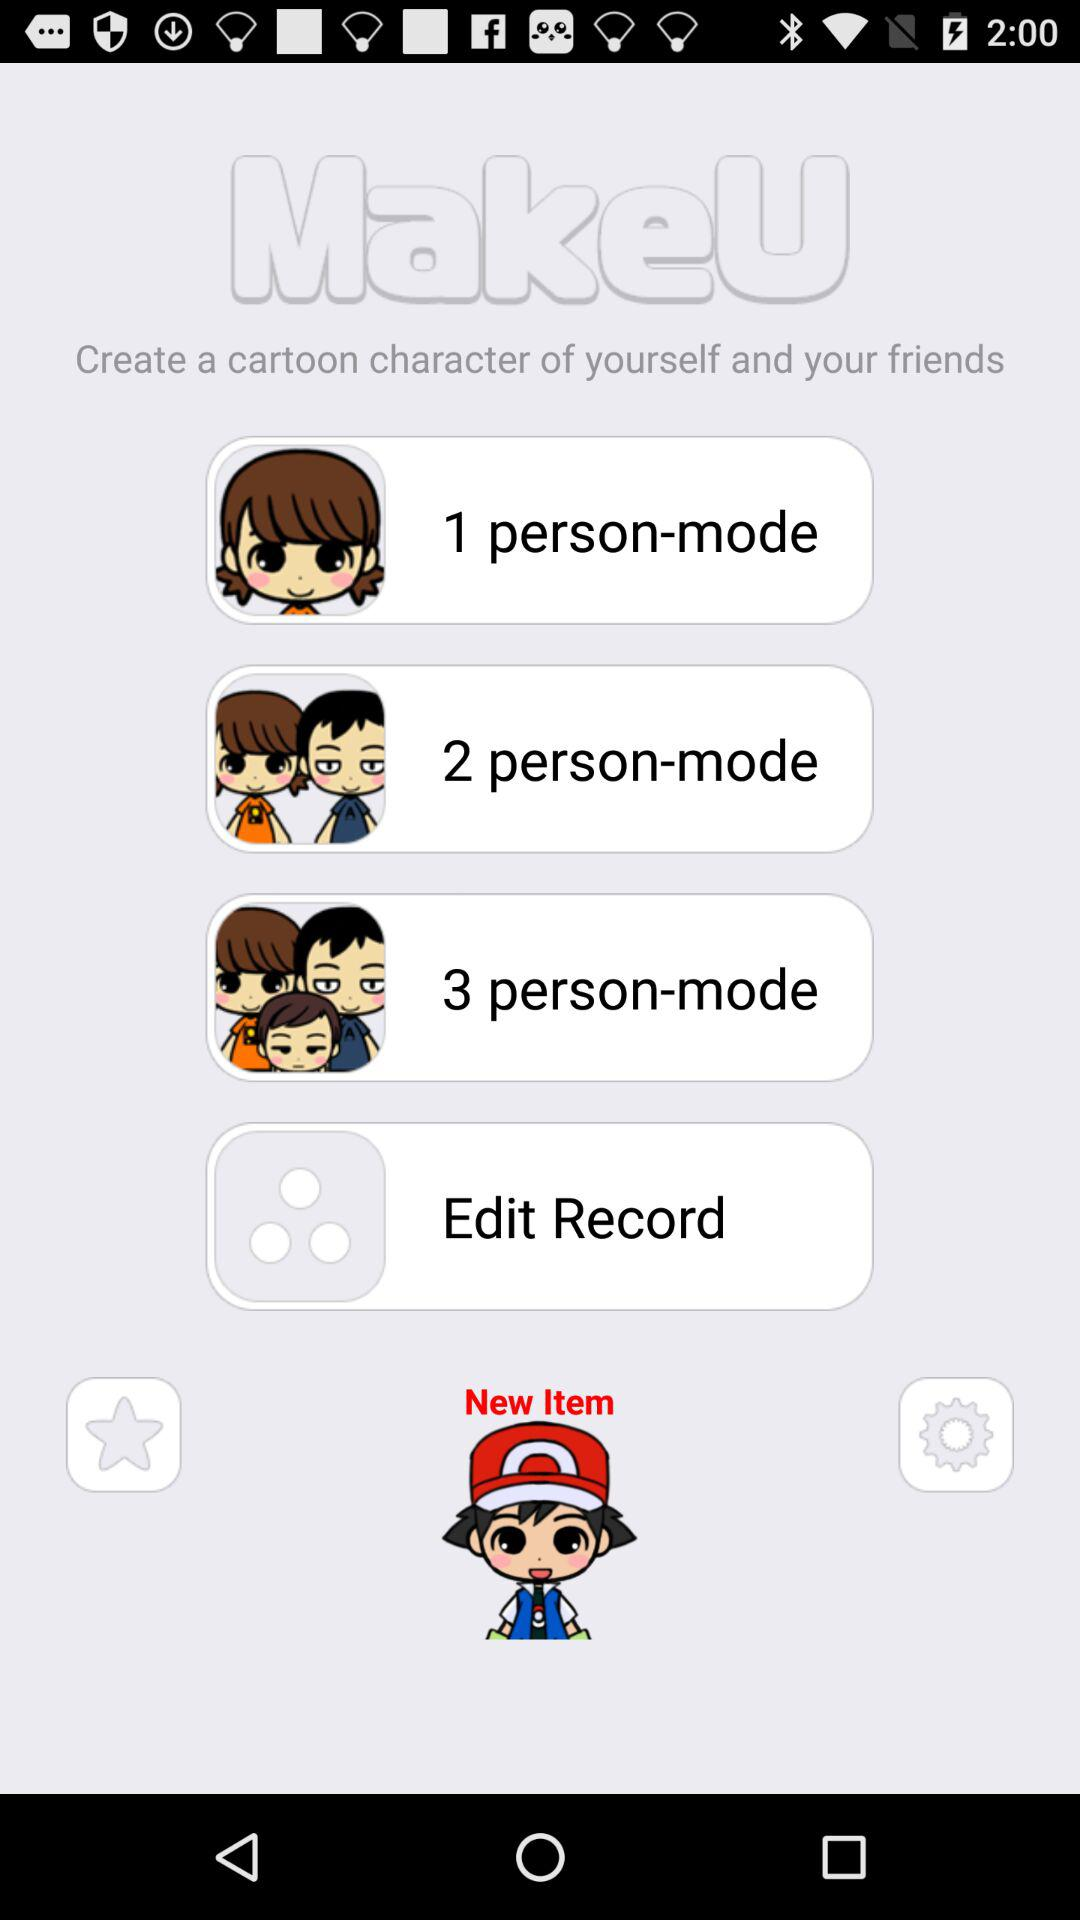How many more people can be drawn in the 3 person mode than the 1 person mode?
Answer the question using a single word or phrase. 2 